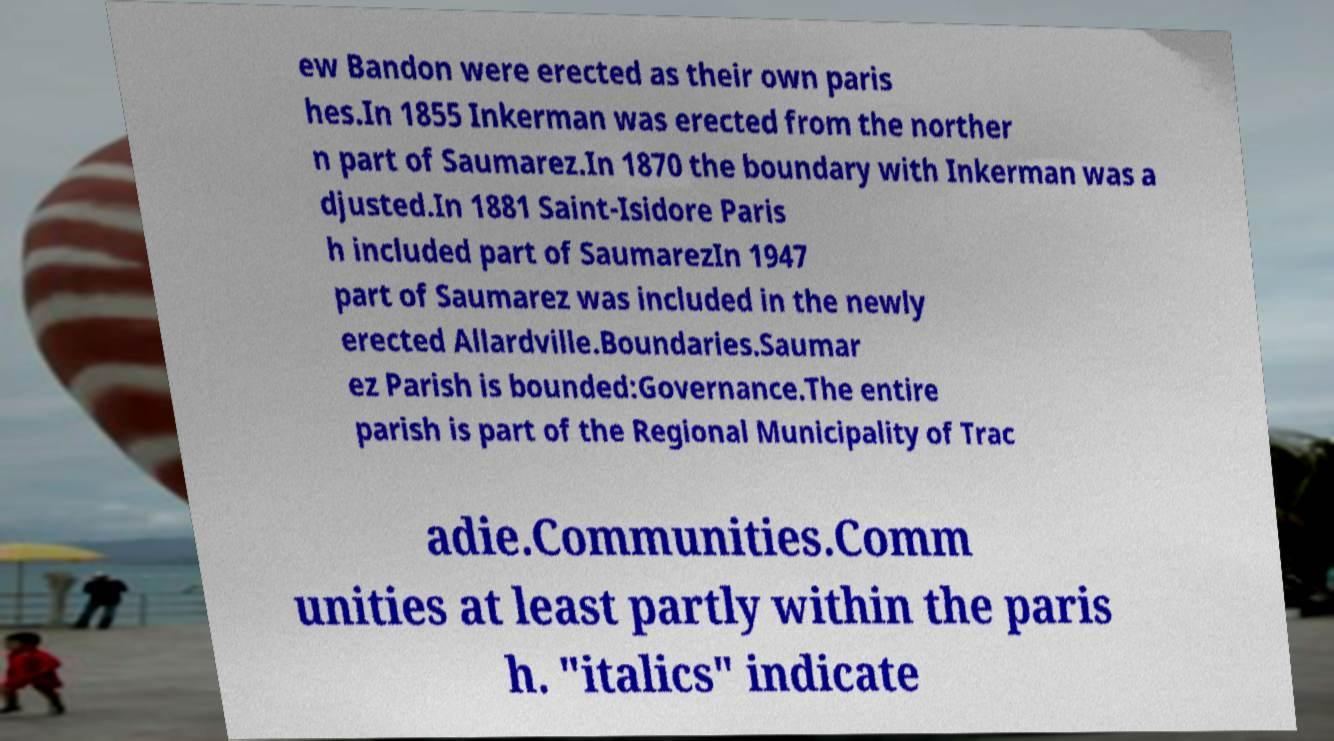Can you accurately transcribe the text from the provided image for me? ew Bandon were erected as their own paris hes.In 1855 Inkerman was erected from the norther n part of Saumarez.In 1870 the boundary with Inkerman was a djusted.In 1881 Saint-Isidore Paris h included part of SaumarezIn 1947 part of Saumarez was included in the newly erected Allardville.Boundaries.Saumar ez Parish is bounded:Governance.The entire parish is part of the Regional Municipality of Trac adie.Communities.Comm unities at least partly within the paris h. "italics" indicate 